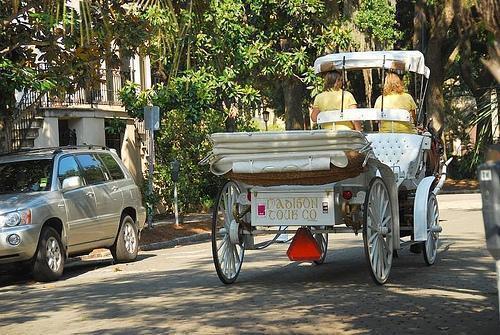How many tourists are in this carrier?
Choose the correct response and explain in the format: 'Answer: answer
Rationale: rationale.'
Options: Two, three, one, none. Answer: none.
Rationale: The tourists would sit in the back of the wagon so there are zero. 